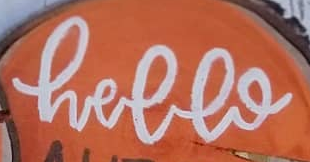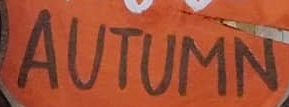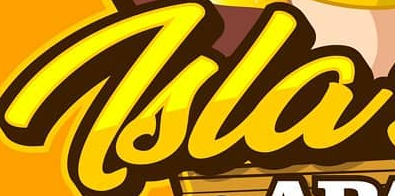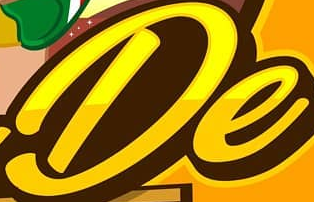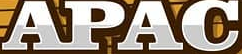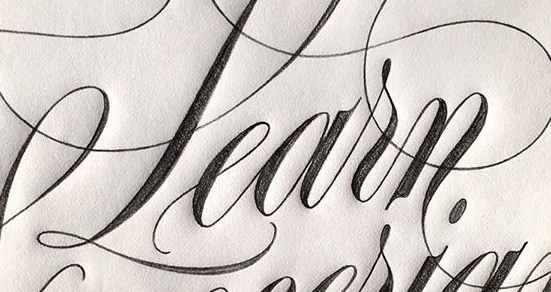Read the text content from these images in order, separated by a semicolon. hello; AUTUMN; Tsla; De; APAC; Learn 